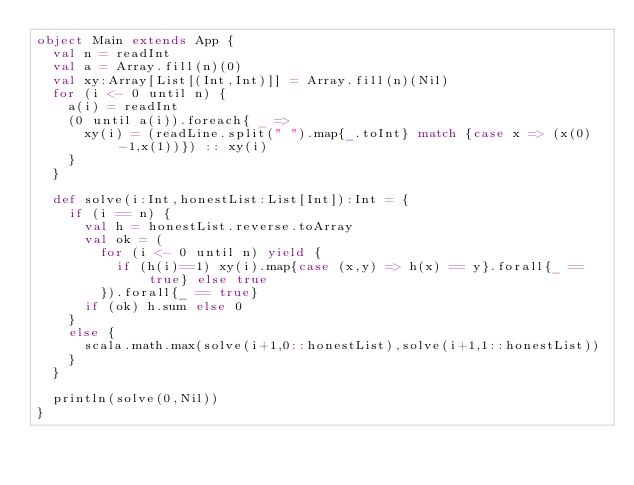Convert code to text. <code><loc_0><loc_0><loc_500><loc_500><_Scala_>object Main extends App {
  val n = readInt
  val a = Array.fill(n)(0)
  val xy:Array[List[(Int,Int)]] = Array.fill(n)(Nil)
  for (i <- 0 until n) {
    a(i) = readInt
    (0 until a(i)).foreach{ _ =>
      xy(i) = (readLine.split(" ").map{_.toInt} match {case x => (x(0)-1,x(1))}) :: xy(i)
    }
  }
  
  def solve(i:Int,honestList:List[Int]):Int = {
    if (i == n) {
      val h = honestList.reverse.toArray
      val ok = (
        for (i <- 0 until n) yield {
          if (h(i)==1) xy(i).map{case (x,y) => h(x) == y}.forall{_ == true} else true
        }).forall{_ == true}
      if (ok) h.sum else 0
    }
    else {
      scala.math.max(solve(i+1,0::honestList),solve(i+1,1::honestList))
    }
  }
  
  println(solve(0,Nil))
}</code> 